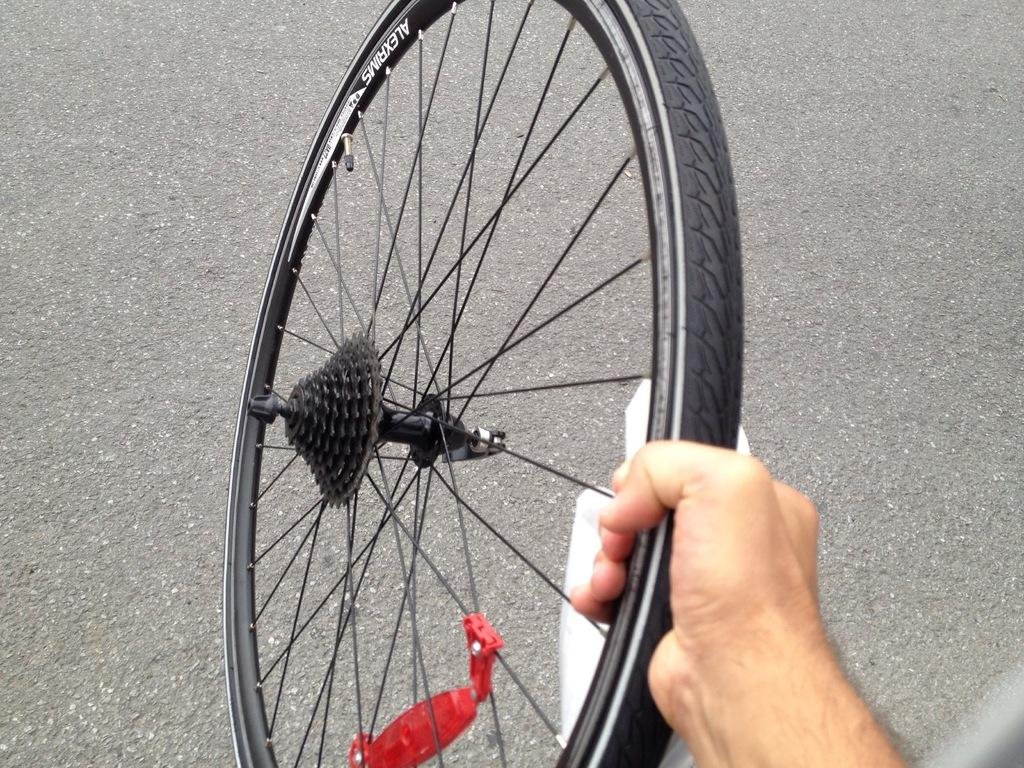What is the main subject in the foreground of the image? There is a hand holding a tire in the foreground of the image. What can be seen in the background of the image? There is a road visible in the background of the image. How many spiders are crawling on the tire in the image? There are no spiders present in the image; it only shows a hand holding a tire. What type of yam is being used to repair the tire in the image? There is no yam present in the image, and the tire is not being repaired. 